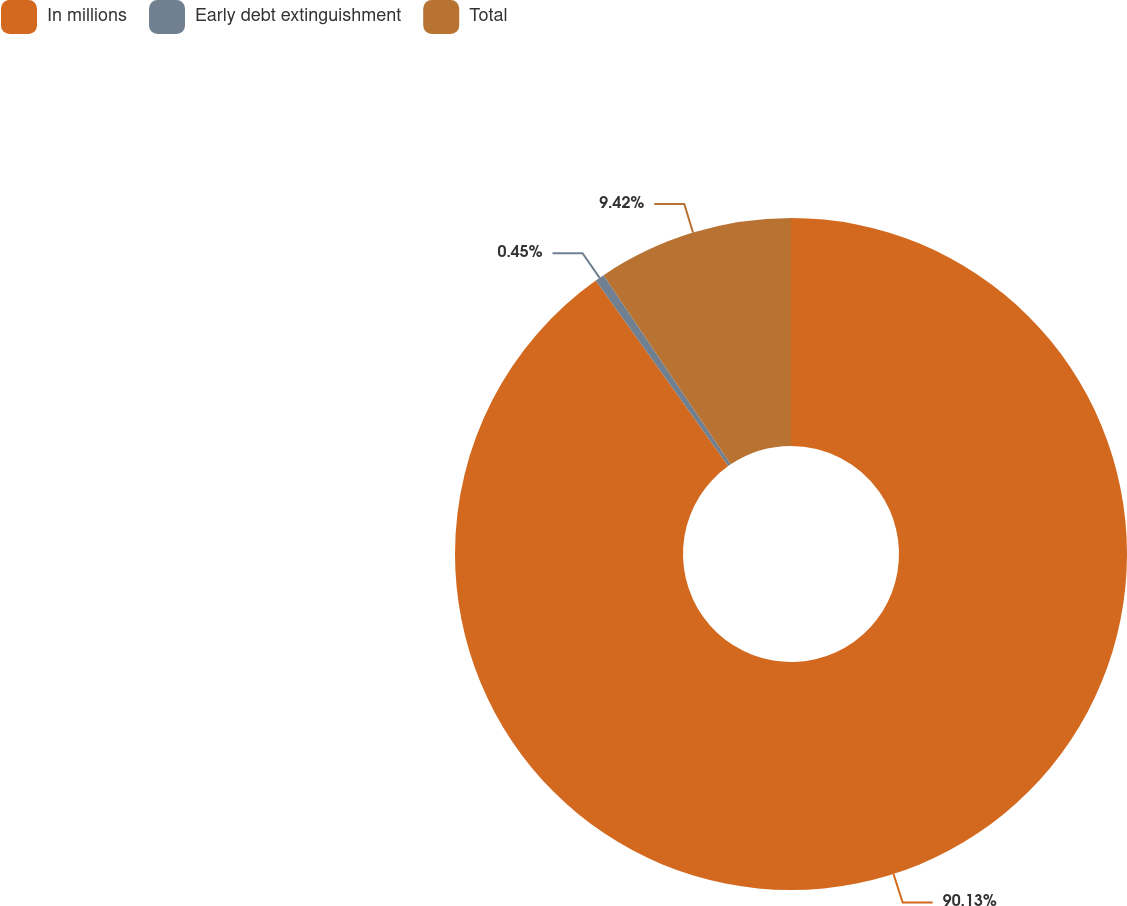<chart> <loc_0><loc_0><loc_500><loc_500><pie_chart><fcel>In millions<fcel>Early debt extinguishment<fcel>Total<nl><fcel>90.14%<fcel>0.45%<fcel>9.42%<nl></chart> 